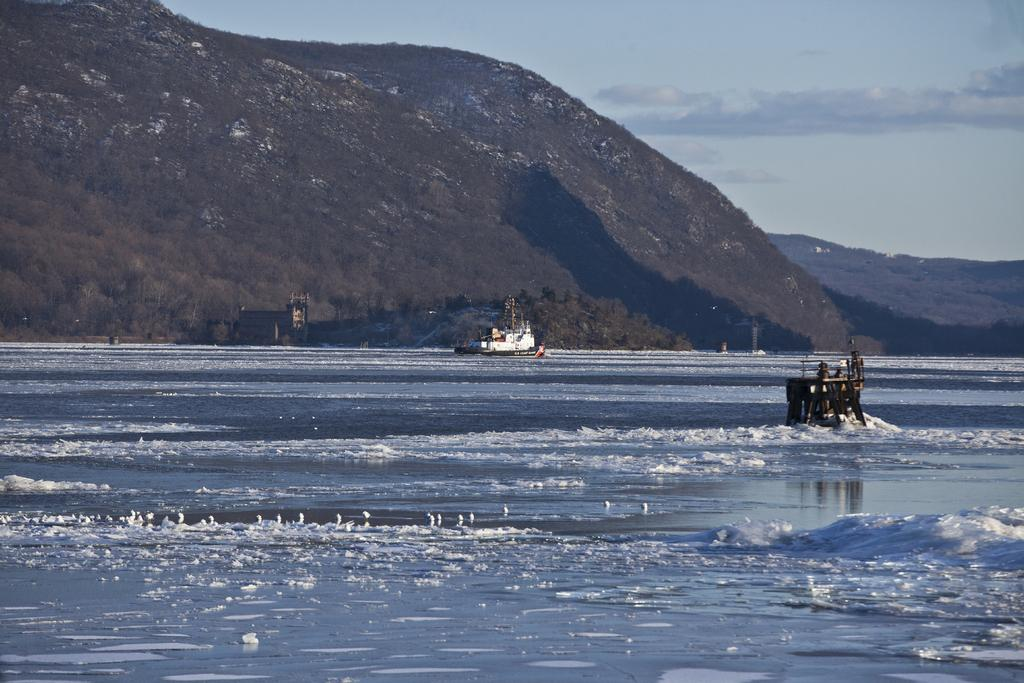What is the main subject of the image? The main subject of the image is ships. What is the ships' location in relation to the water? The ships are floating on water. What can be seen in the background of the image? There are mountains visible in the background of the image. What type of bells can be heard ringing in the image? There are no bells present in the image, and therefore no sound can be heard. 